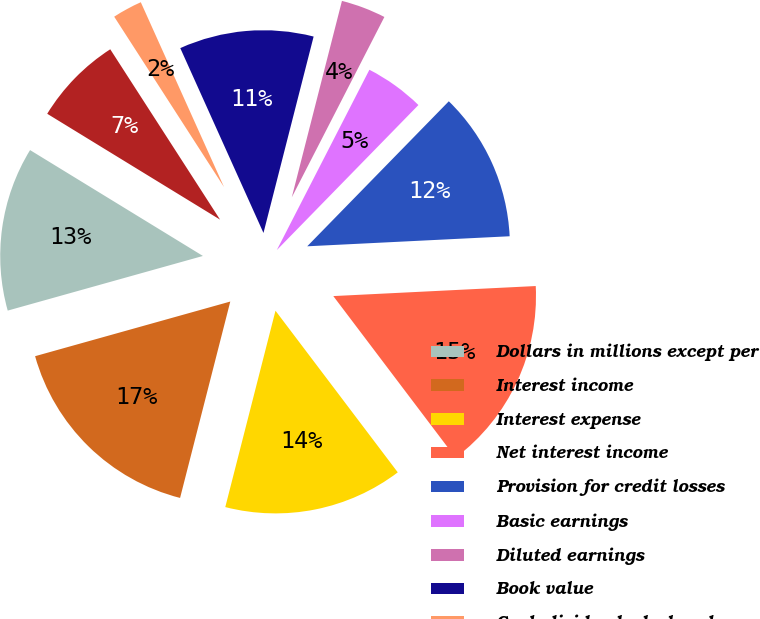Convert chart. <chart><loc_0><loc_0><loc_500><loc_500><pie_chart><fcel>Dollars in millions except per<fcel>Interest income<fcel>Interest expense<fcel>Net interest income<fcel>Provision for credit losses<fcel>Basic earnings<fcel>Diluted earnings<fcel>Book value<fcel>Cash dividends declared<fcel>Effective tax rate (a) (b)<nl><fcel>13.09%<fcel>16.67%<fcel>14.29%<fcel>15.48%<fcel>11.9%<fcel>4.76%<fcel>3.57%<fcel>10.71%<fcel>2.38%<fcel>7.14%<nl></chart> 